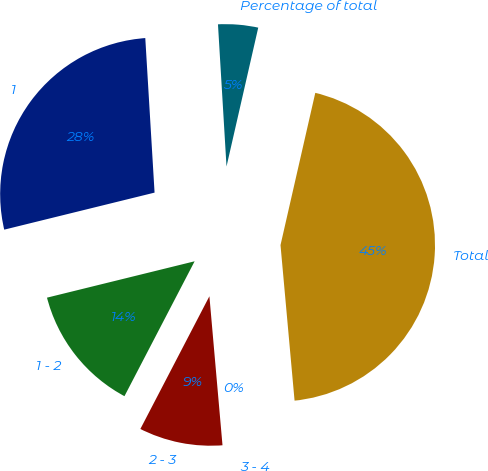Convert chart to OTSL. <chart><loc_0><loc_0><loc_500><loc_500><pie_chart><fcel>1<fcel>1 - 2<fcel>2 - 3<fcel>3 - 4<fcel>Total<fcel>Percentage of total<nl><fcel>27.89%<fcel>13.52%<fcel>9.03%<fcel>0.04%<fcel>44.99%<fcel>4.53%<nl></chart> 